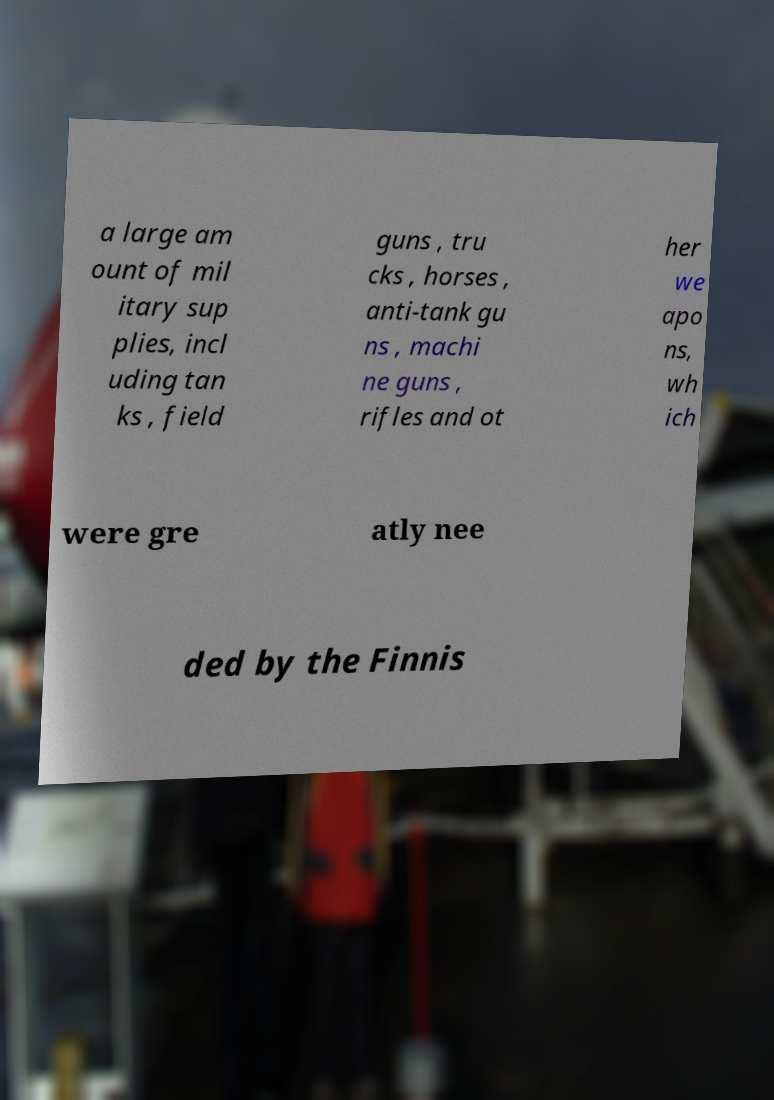Could you assist in decoding the text presented in this image and type it out clearly? a large am ount of mil itary sup plies, incl uding tan ks , field guns , tru cks , horses , anti-tank gu ns , machi ne guns , rifles and ot her we apo ns, wh ich were gre atly nee ded by the Finnis 